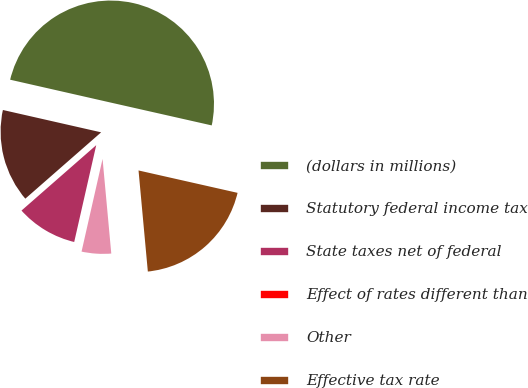<chart> <loc_0><loc_0><loc_500><loc_500><pie_chart><fcel>(dollars in millions)<fcel>Statutory federal income tax<fcel>State taxes net of federal<fcel>Effect of rates different than<fcel>Other<fcel>Effective tax rate<nl><fcel>49.98%<fcel>15.0%<fcel>10.0%<fcel>0.01%<fcel>5.01%<fcel>20.0%<nl></chart> 